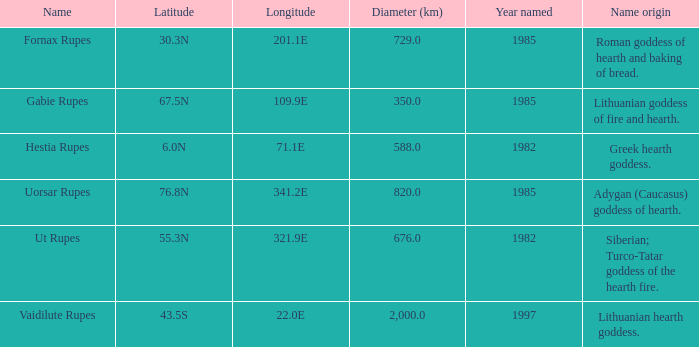Write the full table. {'header': ['Name', 'Latitude', 'Longitude', 'Diameter (km)', 'Year named', 'Name origin'], 'rows': [['Fornax Rupes', '30.3N', '201.1E', '729.0', '1985', 'Roman goddess of hearth and baking of bread.'], ['Gabie Rupes', '67.5N', '109.9E', '350.0', '1985', 'Lithuanian goddess of fire and hearth.'], ['Hestia Rupes', '6.0N', '71.1E', '588.0', '1982', 'Greek hearth goddess.'], ['Uorsar Rupes', '76.8N', '341.2E', '820.0', '1985', 'Adygan (Caucasus) goddess of hearth.'], ['Ut Rupes', '55.3N', '321.9E', '676.0', '1982', 'Siberian; Turco-Tatar goddess of the hearth fire.'], ['Vaidilute Rupes', '43.5S', '22.0E', '2,000.0', '1997', 'Lithuanian hearth goddess.']]} At a latitude of 7 Greek hearth goddess. 